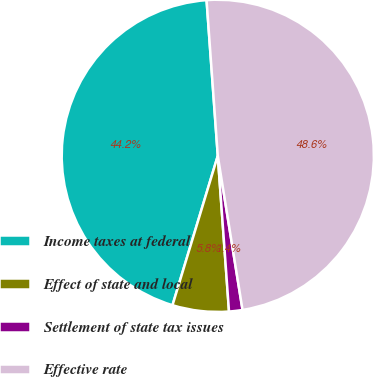<chart> <loc_0><loc_0><loc_500><loc_500><pie_chart><fcel>Income taxes at federal<fcel>Effect of state and local<fcel>Settlement of state tax issues<fcel>Effective rate<nl><fcel>44.17%<fcel>5.83%<fcel>1.39%<fcel>48.61%<nl></chart> 